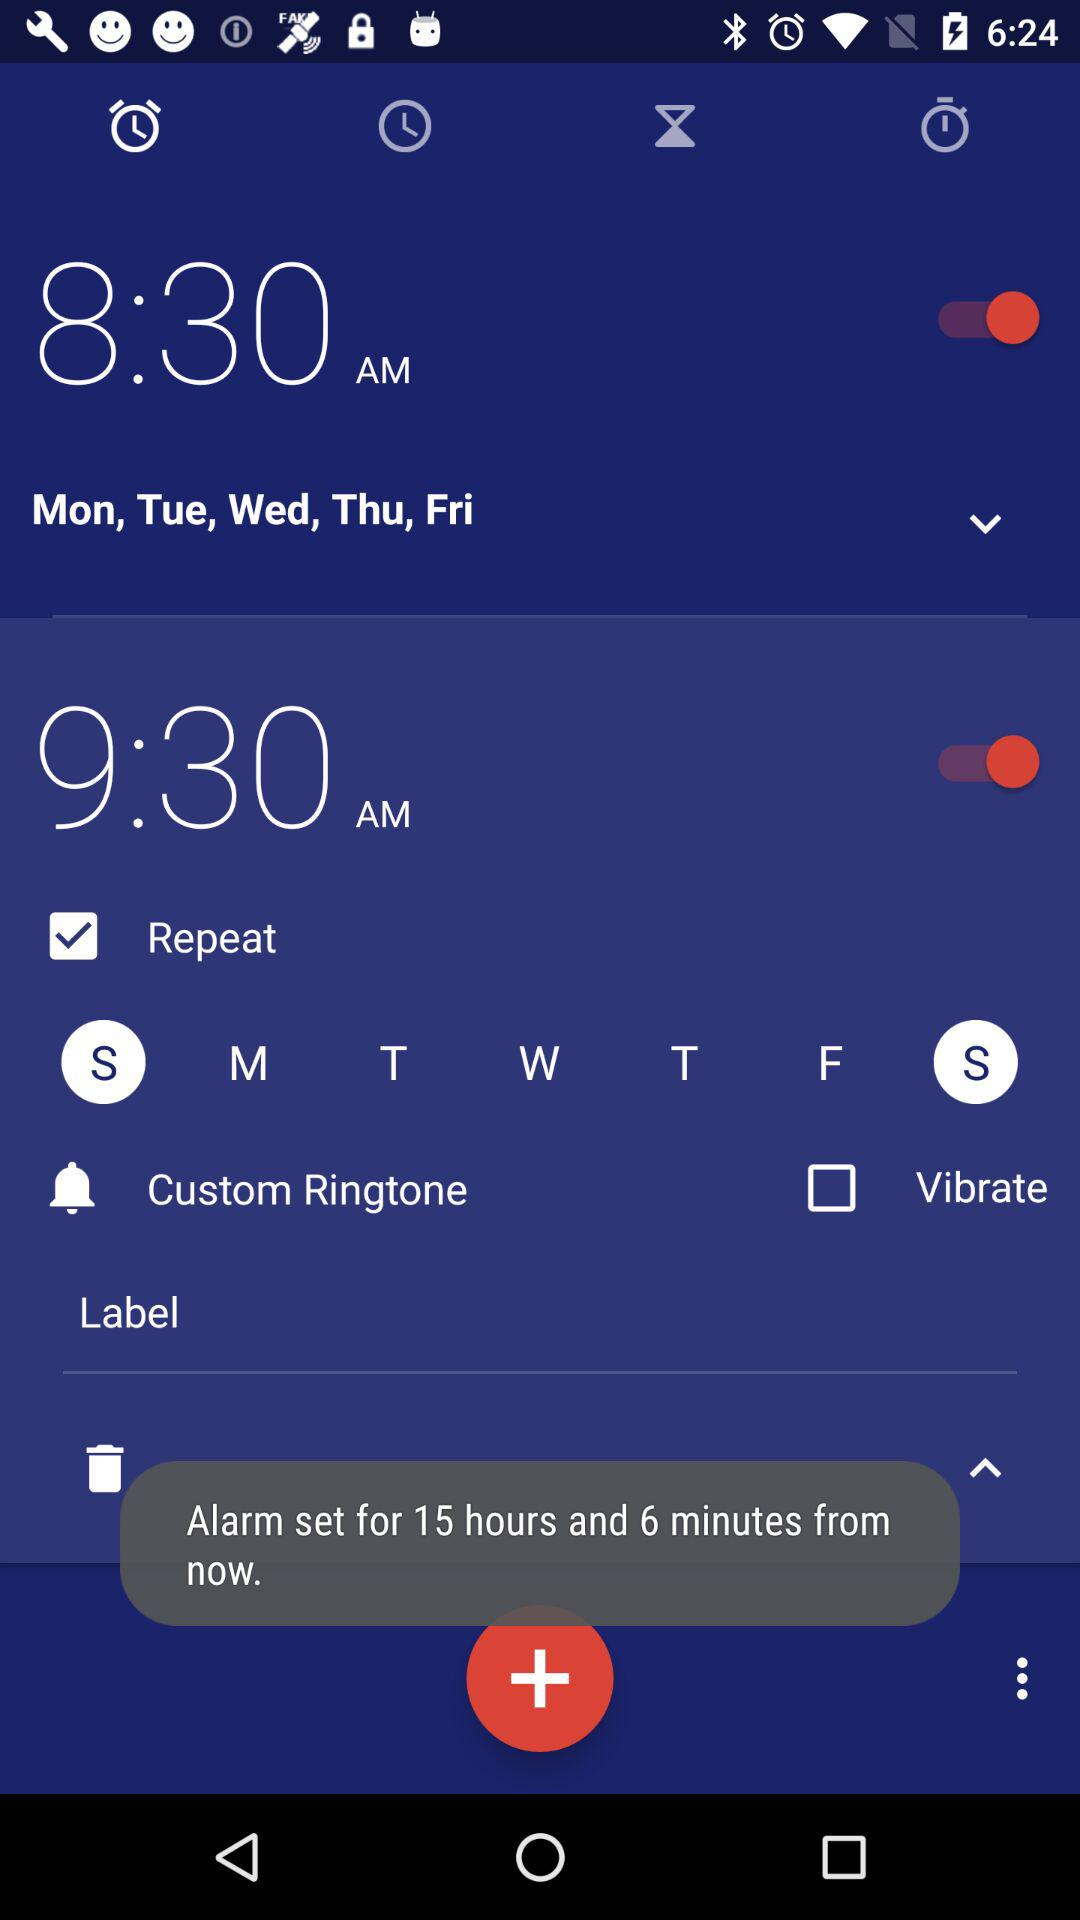What is the status of the alarm for Monday to Friday? The status of the alarm is "on". 